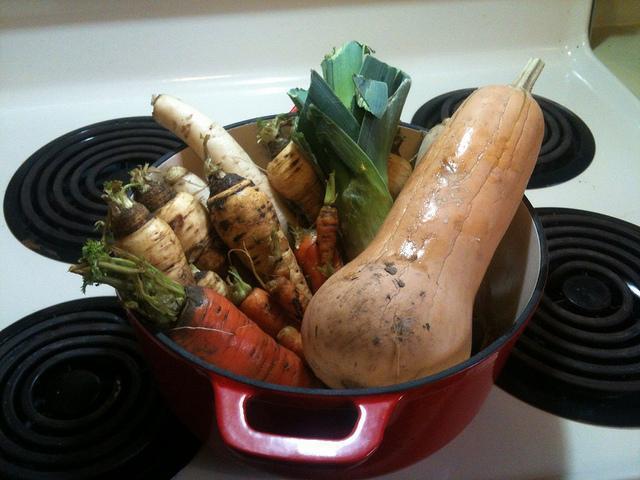How many carrots are there?
Give a very brief answer. 4. 